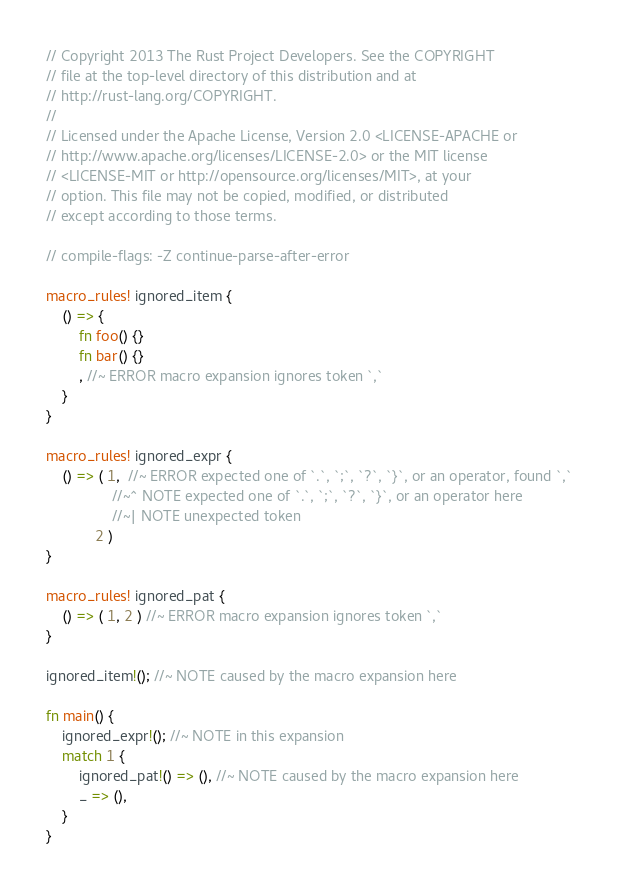<code> <loc_0><loc_0><loc_500><loc_500><_Rust_>// Copyright 2013 The Rust Project Developers. See the COPYRIGHT
// file at the top-level directory of this distribution and at
// http://rust-lang.org/COPYRIGHT.
//
// Licensed under the Apache License, Version 2.0 <LICENSE-APACHE or
// http://www.apache.org/licenses/LICENSE-2.0> or the MIT license
// <LICENSE-MIT or http://opensource.org/licenses/MIT>, at your
// option. This file may not be copied, modified, or distributed
// except according to those terms.

// compile-flags: -Z continue-parse-after-error

macro_rules! ignored_item {
    () => {
        fn foo() {}
        fn bar() {}
        , //~ ERROR macro expansion ignores token `,`
    }
}

macro_rules! ignored_expr {
    () => ( 1,  //~ ERROR expected one of `.`, `;`, `?`, `}`, or an operator, found `,`
                //~^ NOTE expected one of `.`, `;`, `?`, `}`, or an operator here
                //~| NOTE unexpected token
            2 )
}

macro_rules! ignored_pat {
    () => ( 1, 2 ) //~ ERROR macro expansion ignores token `,`
}

ignored_item!(); //~ NOTE caused by the macro expansion here

fn main() {
    ignored_expr!(); //~ NOTE in this expansion
    match 1 {
        ignored_pat!() => (), //~ NOTE caused by the macro expansion here
        _ => (),
    }
}
</code> 